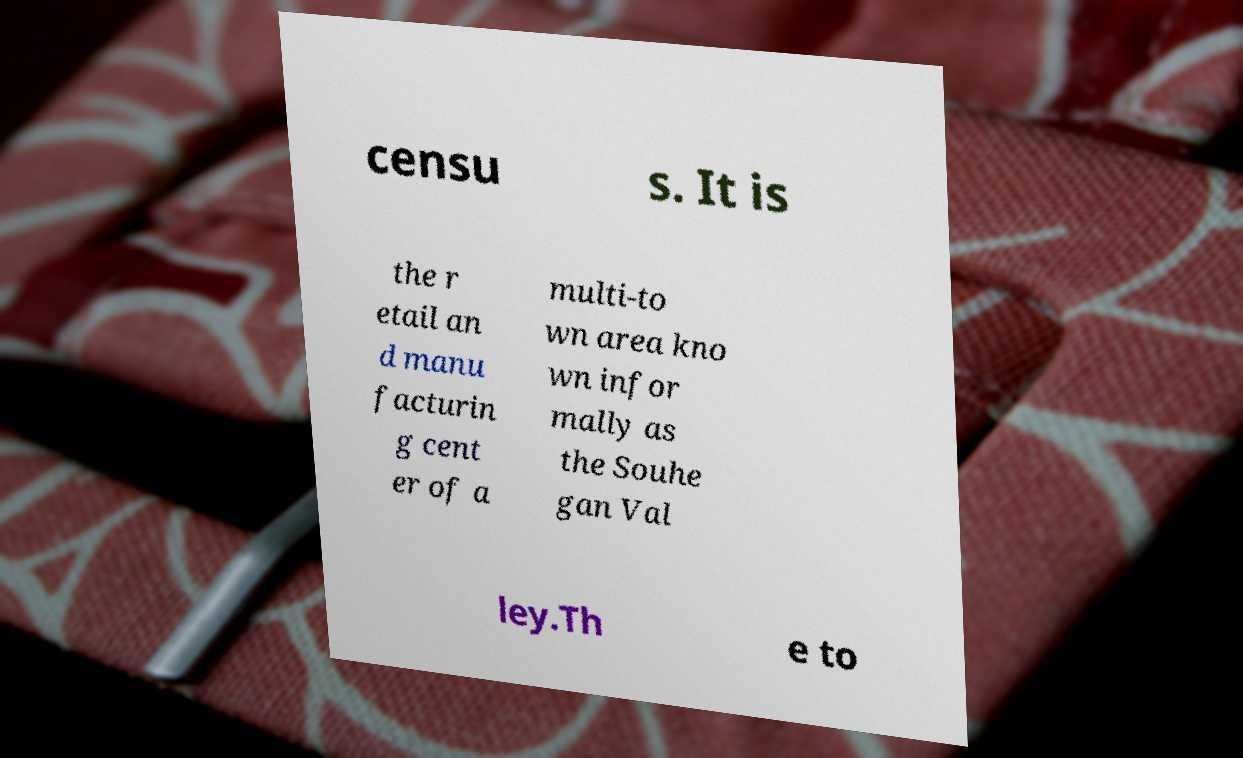Could you extract and type out the text from this image? censu s. It is the r etail an d manu facturin g cent er of a multi-to wn area kno wn infor mally as the Souhe gan Val ley.Th e to 